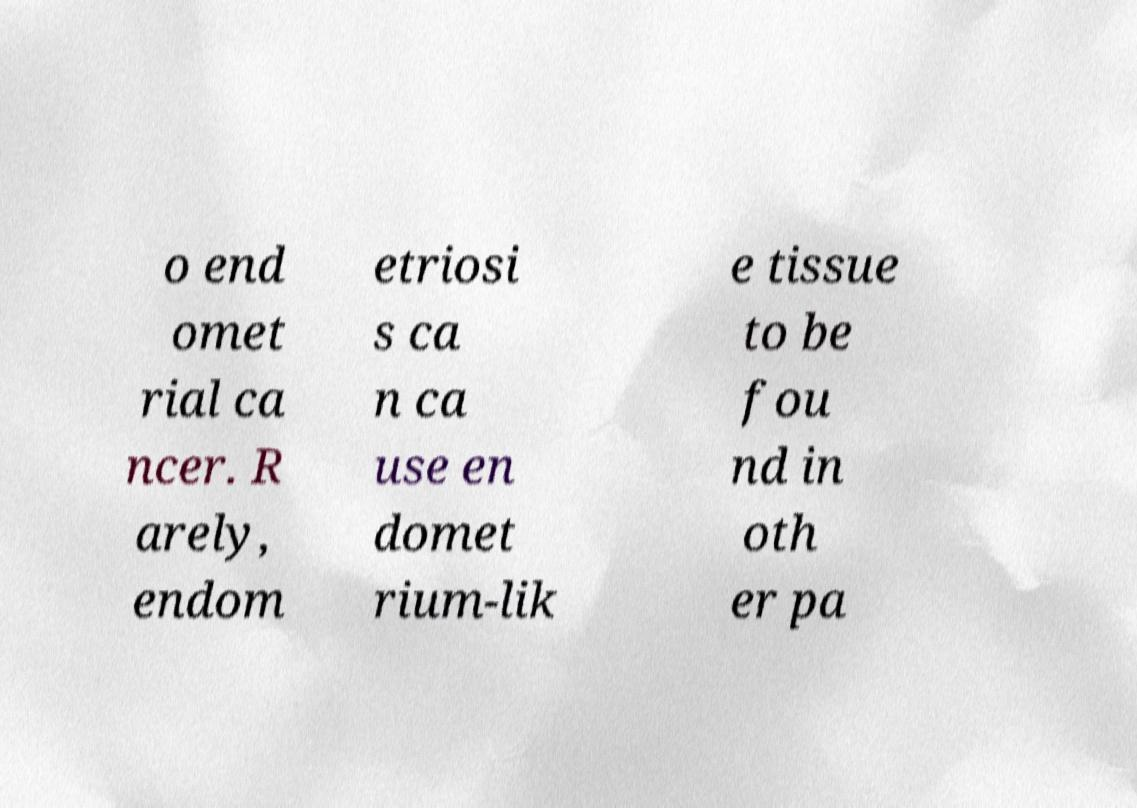Can you accurately transcribe the text from the provided image for me? o end omet rial ca ncer. R arely, endom etriosi s ca n ca use en domet rium-lik e tissue to be fou nd in oth er pa 